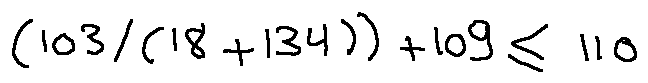<formula> <loc_0><loc_0><loc_500><loc_500>( 1 0 3 / ( 1 8 + 1 3 4 ) ) + 1 0 9 \leq 1 1 0</formula> 